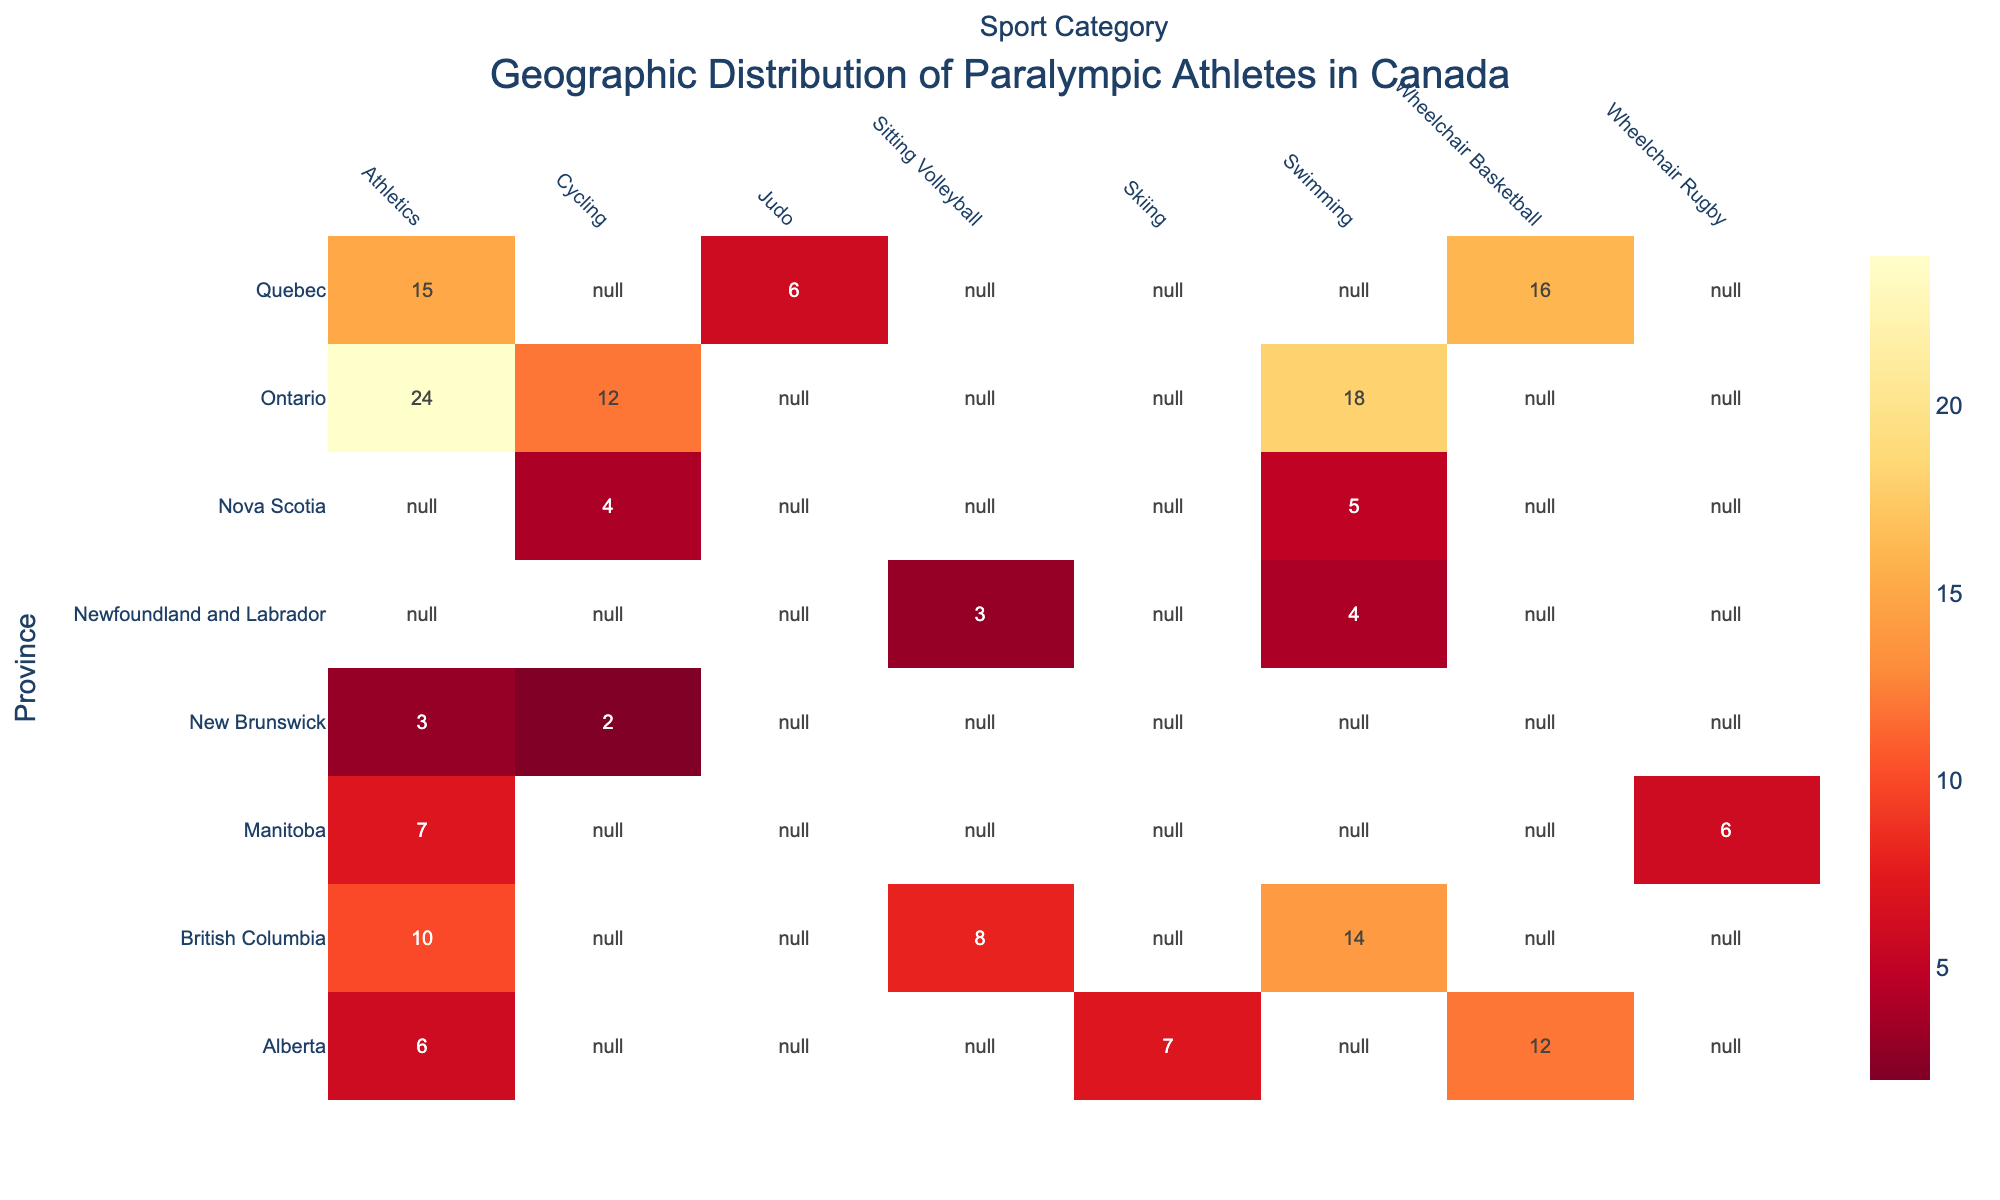What is the title of the heatmap? The title of the heatmap is usually placed at the top of the chart and represents the main information it conveys. In this case, it is designed to show where Canadian Paralympic athletes are from by province and sport category.
Answer: Geographic Distribution of Paralympic Athletes in Canada Which province has the most athletes in Wheelchair Basketball? Look at the row for each province and find the column for Wheelchair Basketball to see which cell has the highest value.
Answer: Quebec How many athletes in total are represented from Alberta? Add up all the athletes from Alberta by summing its row values: Athletics (6), Wheelchair Basketball (12), and Skiing (7).
Answer: 25 Which sport category has the highest number of athletes in Ontario? Check the row for Ontario and find the highest value among the sport categories: Athletics (24), Swimming (18), and Cycling (12).
Answer: Athletics What is the total number of Swimming athletes from all provinces? Add up all the values in the Swimming column: Ontario (18), British Columbia (14), Newfoundland and Labrador (4), and Nova Scotia (5).
Answer: 41 Which province has the least number of athletes represented in the heatmap? Compare the total number of athletes for each province by summing the rows: Manitoba (13), New Brunswick (5), Newfoundland and Labrador (7), etc., and find the smallest sum.
Answer: New Brunswick Does Nova Scotia have more athletes in Swimming or Cycling? Compare the values in the row for Nova Scotia in the Swimming column and the Cycling column: Swimming (5) and Cycling (4).
Answer: Swimming Are there more Cycling athletes in Ontario or Athletics athletes in Manitoba? Compare the values: Cycling in Ontario (12) and Athletics in Manitoba (7).
Answer: Ontario Which provinces have data points (athletes) for Sitting Volleyball? Look at the Sitting Volleyball column and check which rows (provinces) have values: British Columbia and Newfoundland and Labrador.
Answer: British Columbia, Newfoundland and Labrador What's the average number of Cycling athletes per province? Add the total number of Cycling athletes from all provinces and divide by the number of provinces with Cycling athletes: Ontario (12), Nova Scotia (4), New Brunswick (2), and divide by 3 provinces.
Answer: 6 